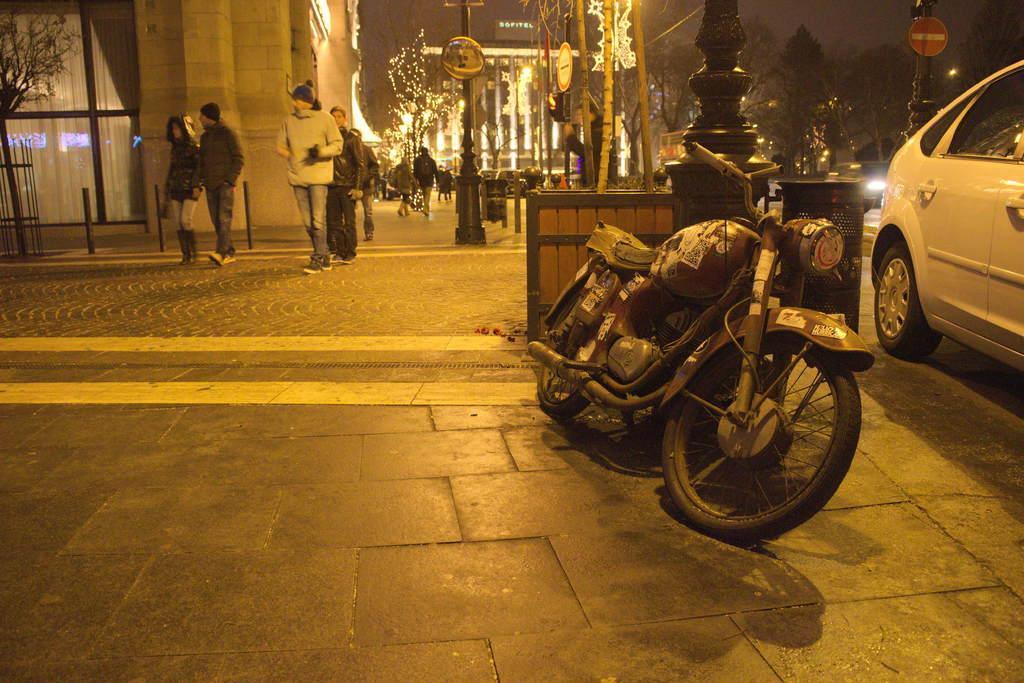In one or two sentences, can you explain what this image depicts? The picture is taken outside a city. In the foreground of the picture there are car, bike and footpath. In the center of the picture there are people walking. On the footpath and there are poles, lights, trees, curtain and buildings. 